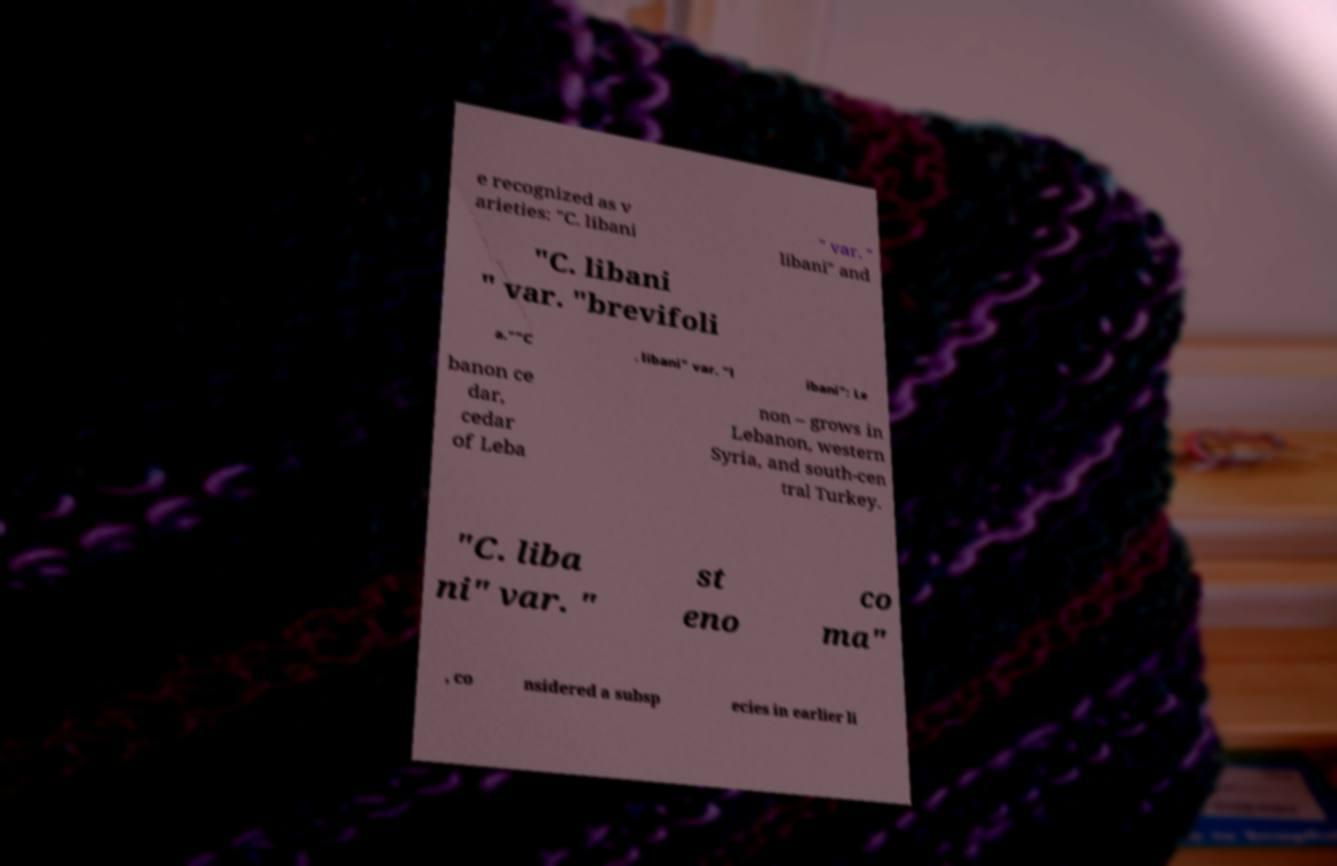Could you assist in decoding the text presented in this image and type it out clearly? e recognized as v arieties: "C. libani " var. " libani" and "C. libani " var. "brevifoli a.""C . libani" var. "l ibani": Le banon ce dar, cedar of Leba non – grows in Lebanon, western Syria, and south-cen tral Turkey. "C. liba ni" var. " st eno co ma" , co nsidered a subsp ecies in earlier li 